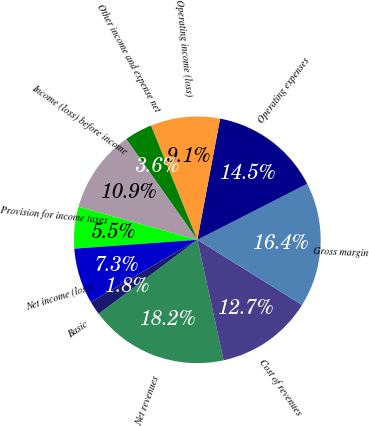Convert chart to OTSL. <chart><loc_0><loc_0><loc_500><loc_500><pie_chart><fcel>Net revenues<fcel>Cost of revenues<fcel>Gross margin<fcel>Operating expenses<fcel>Operating income (loss)<fcel>Other income and expense net<fcel>Income (loss) before income<fcel>Provision for income taxes<fcel>Net income (loss)<fcel>Basic<nl><fcel>18.18%<fcel>12.73%<fcel>16.36%<fcel>14.54%<fcel>9.09%<fcel>3.64%<fcel>10.91%<fcel>5.46%<fcel>7.27%<fcel>1.82%<nl></chart> 